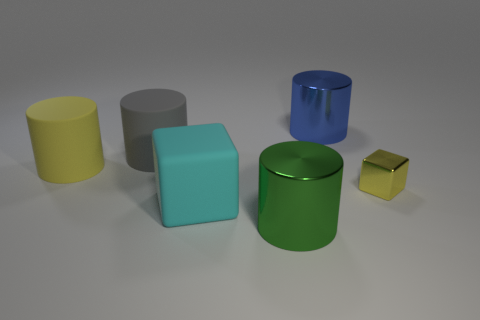Is there anything else that is the same size as the shiny cube?
Offer a very short reply. No. What is the large blue object made of?
Make the answer very short. Metal. There is a cube that is the same material as the large yellow thing; what is its color?
Ensure brevity in your answer.  Cyan. Does the large gray object have the same material as the big cylinder that is in front of the large yellow rubber object?
Make the answer very short. No. What number of objects are made of the same material as the gray cylinder?
Offer a very short reply. 2. What shape is the thing that is to the left of the gray matte thing?
Make the answer very short. Cylinder. Is the cylinder right of the green metallic cylinder made of the same material as the yellow object that is on the right side of the big yellow thing?
Give a very brief answer. Yes. Are there any other shiny objects of the same shape as the cyan thing?
Provide a short and direct response. Yes. How many objects are either objects that are in front of the big yellow rubber cylinder or yellow blocks?
Give a very brief answer. 3. Is the number of yellow things on the left side of the tiny yellow metal thing greater than the number of large rubber cylinders behind the large yellow rubber cylinder?
Ensure brevity in your answer.  No. 